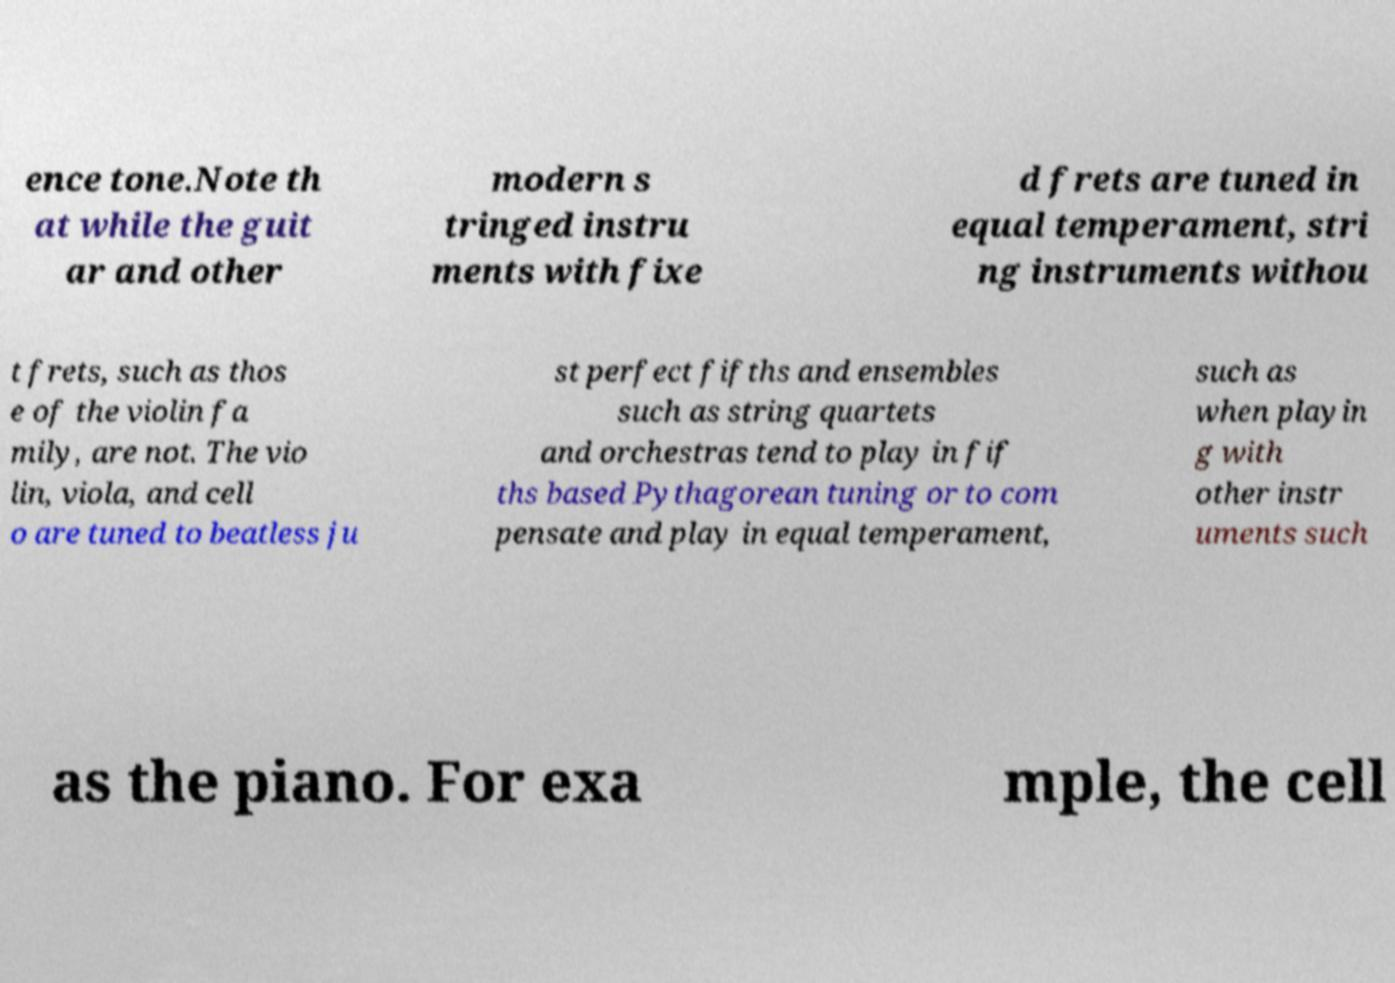Please identify and transcribe the text found in this image. ence tone.Note th at while the guit ar and other modern s tringed instru ments with fixe d frets are tuned in equal temperament, stri ng instruments withou t frets, such as thos e of the violin fa mily, are not. The vio lin, viola, and cell o are tuned to beatless ju st perfect fifths and ensembles such as string quartets and orchestras tend to play in fif ths based Pythagorean tuning or to com pensate and play in equal temperament, such as when playin g with other instr uments such as the piano. For exa mple, the cell 